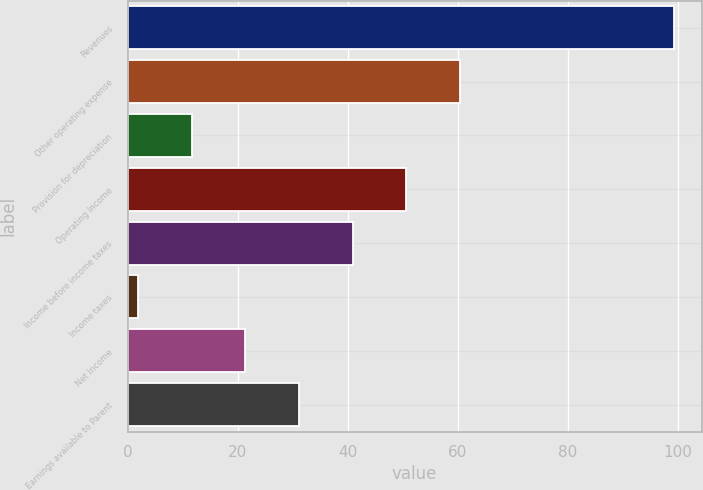Convert chart to OTSL. <chart><loc_0><loc_0><loc_500><loc_500><bar_chart><fcel>Revenues<fcel>Other operating expense<fcel>Provision for depreciation<fcel>Operating Income<fcel>Income before income taxes<fcel>Income taxes<fcel>Net Income<fcel>Earnings available to Parent<nl><fcel>99.3<fcel>60.34<fcel>11.64<fcel>50.6<fcel>40.86<fcel>1.9<fcel>21.38<fcel>31.12<nl></chart> 